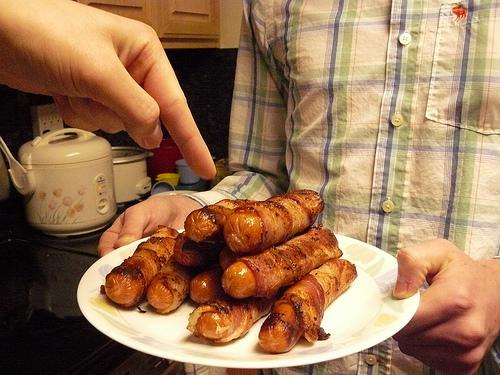Question: why was the picture taken?
Choices:
A. To keep memories.
B. For a joke.
C. For business.
D. To capture the hot dogs.
Answer with the letter. Answer: D Question: where was the picture taken?
Choices:
A. In a kitchen.
B. Hospital.
C. Zoo.
D. Park.
Answer with the letter. Answer: A Question: who is holding the food?
Choices:
A. Lady.
B. Child.
C. A man.
D. Baby.
Answer with the letter. Answer: C Question: what is the person pointing at?
Choices:
A. Dog.
B. Cat.
C. Bird.
D. The hot dogs.
Answer with the letter. Answer: D 